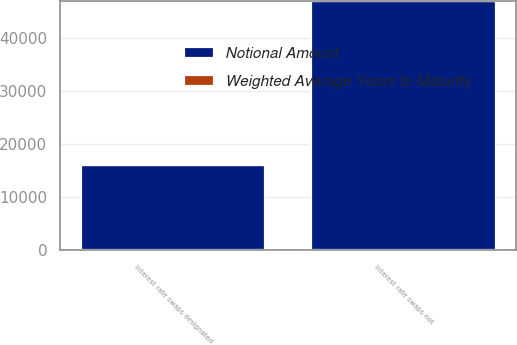<chart> <loc_0><loc_0><loc_500><loc_500><stacked_bar_chart><ecel><fcel>Interest rate swaps designated<fcel>Interest rate swaps not<nl><fcel>Notional Amount<fcel>16048<fcel>46952<nl><fcel>Weighted Average Years to Maturity<fcel>0<fcel>0.3<nl></chart> 